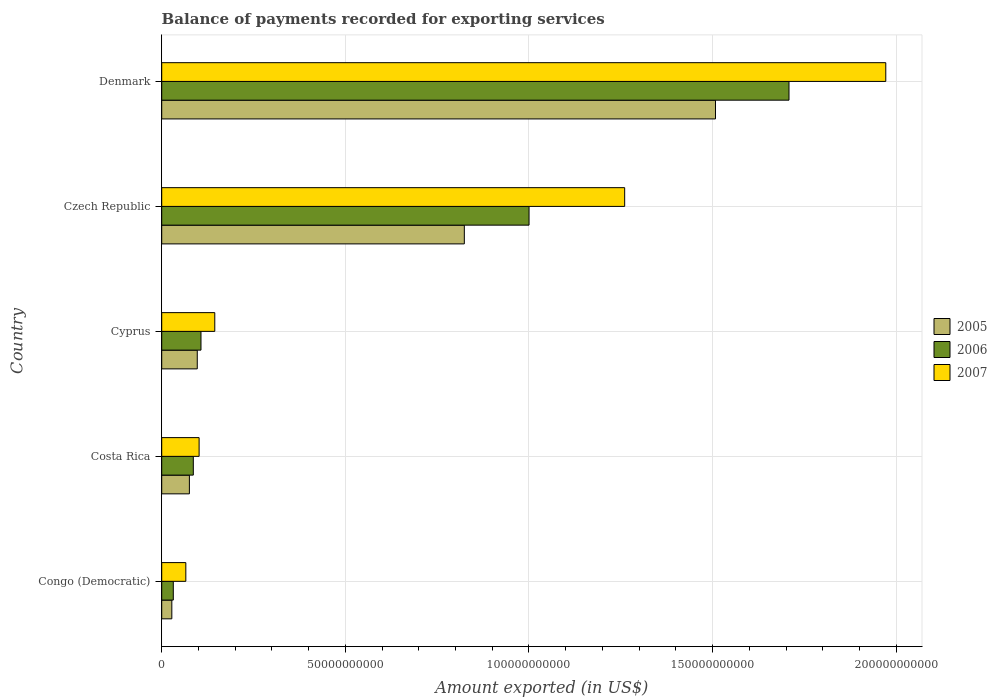How many groups of bars are there?
Provide a succinct answer. 5. Are the number of bars per tick equal to the number of legend labels?
Keep it short and to the point. Yes. What is the label of the 1st group of bars from the top?
Give a very brief answer. Denmark. In how many cases, is the number of bars for a given country not equal to the number of legend labels?
Give a very brief answer. 0. What is the amount exported in 2006 in Cyprus?
Keep it short and to the point. 1.07e+1. Across all countries, what is the maximum amount exported in 2005?
Ensure brevity in your answer.  1.51e+11. Across all countries, what is the minimum amount exported in 2006?
Your answer should be compact. 3.16e+09. In which country was the amount exported in 2007 maximum?
Your answer should be compact. Denmark. In which country was the amount exported in 2007 minimum?
Offer a very short reply. Congo (Democratic). What is the total amount exported in 2005 in the graph?
Give a very brief answer. 2.53e+11. What is the difference between the amount exported in 2005 in Congo (Democratic) and that in Denmark?
Ensure brevity in your answer.  -1.48e+11. What is the difference between the amount exported in 2007 in Cyprus and the amount exported in 2005 in Congo (Democratic)?
Provide a short and direct response. 1.17e+1. What is the average amount exported in 2005 per country?
Provide a succinct answer. 5.06e+1. What is the difference between the amount exported in 2005 and amount exported in 2007 in Czech Republic?
Your answer should be very brief. -4.37e+1. In how many countries, is the amount exported in 2007 greater than 140000000000 US$?
Your answer should be very brief. 1. What is the ratio of the amount exported in 2007 in Cyprus to that in Czech Republic?
Ensure brevity in your answer.  0.11. Is the amount exported in 2005 in Congo (Democratic) less than that in Cyprus?
Provide a succinct answer. Yes. What is the difference between the highest and the second highest amount exported in 2006?
Ensure brevity in your answer.  7.08e+1. What is the difference between the highest and the lowest amount exported in 2006?
Offer a very short reply. 1.68e+11. Is the sum of the amount exported in 2005 in Costa Rica and Denmark greater than the maximum amount exported in 2007 across all countries?
Provide a short and direct response. No. What does the 2nd bar from the top in Cyprus represents?
Provide a short and direct response. 2006. Is it the case that in every country, the sum of the amount exported in 2005 and amount exported in 2006 is greater than the amount exported in 2007?
Provide a succinct answer. No. How many bars are there?
Provide a short and direct response. 15. How many countries are there in the graph?
Your answer should be very brief. 5. What is the difference between two consecutive major ticks on the X-axis?
Provide a short and direct response. 5.00e+1. Are the values on the major ticks of X-axis written in scientific E-notation?
Make the answer very short. No. What is the title of the graph?
Your answer should be very brief. Balance of payments recorded for exporting services. Does "1995" appear as one of the legend labels in the graph?
Your answer should be very brief. No. What is the label or title of the X-axis?
Your answer should be compact. Amount exported (in US$). What is the Amount exported (in US$) of 2005 in Congo (Democratic)?
Make the answer very short. 2.76e+09. What is the Amount exported (in US$) of 2006 in Congo (Democratic)?
Keep it short and to the point. 3.16e+09. What is the Amount exported (in US$) in 2007 in Congo (Democratic)?
Give a very brief answer. 6.57e+09. What is the Amount exported (in US$) of 2005 in Costa Rica?
Ensure brevity in your answer.  7.54e+09. What is the Amount exported (in US$) in 2006 in Costa Rica?
Your response must be concise. 8.60e+09. What is the Amount exported (in US$) in 2007 in Costa Rica?
Your response must be concise. 1.02e+1. What is the Amount exported (in US$) in 2005 in Cyprus?
Your answer should be very brief. 9.68e+09. What is the Amount exported (in US$) of 2006 in Cyprus?
Give a very brief answer. 1.07e+1. What is the Amount exported (in US$) of 2007 in Cyprus?
Provide a succinct answer. 1.44e+1. What is the Amount exported (in US$) of 2005 in Czech Republic?
Make the answer very short. 8.24e+1. What is the Amount exported (in US$) in 2006 in Czech Republic?
Keep it short and to the point. 1.00e+11. What is the Amount exported (in US$) in 2007 in Czech Republic?
Keep it short and to the point. 1.26e+11. What is the Amount exported (in US$) in 2005 in Denmark?
Provide a short and direct response. 1.51e+11. What is the Amount exported (in US$) in 2006 in Denmark?
Offer a very short reply. 1.71e+11. What is the Amount exported (in US$) of 2007 in Denmark?
Your answer should be compact. 1.97e+11. Across all countries, what is the maximum Amount exported (in US$) in 2005?
Ensure brevity in your answer.  1.51e+11. Across all countries, what is the maximum Amount exported (in US$) of 2006?
Keep it short and to the point. 1.71e+11. Across all countries, what is the maximum Amount exported (in US$) in 2007?
Provide a succinct answer. 1.97e+11. Across all countries, what is the minimum Amount exported (in US$) of 2005?
Your answer should be compact. 2.76e+09. Across all countries, what is the minimum Amount exported (in US$) in 2006?
Make the answer very short. 3.16e+09. Across all countries, what is the minimum Amount exported (in US$) of 2007?
Make the answer very short. 6.57e+09. What is the total Amount exported (in US$) of 2005 in the graph?
Ensure brevity in your answer.  2.53e+11. What is the total Amount exported (in US$) of 2006 in the graph?
Keep it short and to the point. 2.93e+11. What is the total Amount exported (in US$) in 2007 in the graph?
Keep it short and to the point. 3.54e+11. What is the difference between the Amount exported (in US$) in 2005 in Congo (Democratic) and that in Costa Rica?
Make the answer very short. -4.78e+09. What is the difference between the Amount exported (in US$) of 2006 in Congo (Democratic) and that in Costa Rica?
Your answer should be very brief. -5.45e+09. What is the difference between the Amount exported (in US$) in 2007 in Congo (Democratic) and that in Costa Rica?
Offer a very short reply. -3.62e+09. What is the difference between the Amount exported (in US$) of 2005 in Congo (Democratic) and that in Cyprus?
Your response must be concise. -6.93e+09. What is the difference between the Amount exported (in US$) of 2006 in Congo (Democratic) and that in Cyprus?
Your answer should be compact. -7.54e+09. What is the difference between the Amount exported (in US$) in 2007 in Congo (Democratic) and that in Cyprus?
Keep it short and to the point. -7.88e+09. What is the difference between the Amount exported (in US$) in 2005 in Congo (Democratic) and that in Czech Republic?
Your answer should be compact. -7.96e+1. What is the difference between the Amount exported (in US$) in 2006 in Congo (Democratic) and that in Czech Republic?
Make the answer very short. -9.69e+1. What is the difference between the Amount exported (in US$) of 2007 in Congo (Democratic) and that in Czech Republic?
Your answer should be compact. -1.19e+11. What is the difference between the Amount exported (in US$) in 2005 in Congo (Democratic) and that in Denmark?
Your answer should be very brief. -1.48e+11. What is the difference between the Amount exported (in US$) in 2006 in Congo (Democratic) and that in Denmark?
Provide a succinct answer. -1.68e+11. What is the difference between the Amount exported (in US$) of 2007 in Congo (Democratic) and that in Denmark?
Make the answer very short. -1.91e+11. What is the difference between the Amount exported (in US$) in 2005 in Costa Rica and that in Cyprus?
Give a very brief answer. -2.15e+09. What is the difference between the Amount exported (in US$) in 2006 in Costa Rica and that in Cyprus?
Your response must be concise. -2.09e+09. What is the difference between the Amount exported (in US$) of 2007 in Costa Rica and that in Cyprus?
Provide a succinct answer. -4.27e+09. What is the difference between the Amount exported (in US$) in 2005 in Costa Rica and that in Czech Republic?
Give a very brief answer. -7.49e+1. What is the difference between the Amount exported (in US$) in 2006 in Costa Rica and that in Czech Republic?
Your answer should be compact. -9.14e+1. What is the difference between the Amount exported (in US$) in 2007 in Costa Rica and that in Czech Republic?
Offer a terse response. -1.16e+11. What is the difference between the Amount exported (in US$) in 2005 in Costa Rica and that in Denmark?
Offer a very short reply. -1.43e+11. What is the difference between the Amount exported (in US$) of 2006 in Costa Rica and that in Denmark?
Provide a short and direct response. -1.62e+11. What is the difference between the Amount exported (in US$) in 2007 in Costa Rica and that in Denmark?
Offer a very short reply. -1.87e+11. What is the difference between the Amount exported (in US$) in 2005 in Cyprus and that in Czech Republic?
Your answer should be compact. -7.27e+1. What is the difference between the Amount exported (in US$) in 2006 in Cyprus and that in Czech Republic?
Your response must be concise. -8.93e+1. What is the difference between the Amount exported (in US$) of 2007 in Cyprus and that in Czech Republic?
Ensure brevity in your answer.  -1.12e+11. What is the difference between the Amount exported (in US$) of 2005 in Cyprus and that in Denmark?
Provide a short and direct response. -1.41e+11. What is the difference between the Amount exported (in US$) of 2006 in Cyprus and that in Denmark?
Give a very brief answer. -1.60e+11. What is the difference between the Amount exported (in US$) of 2007 in Cyprus and that in Denmark?
Provide a short and direct response. -1.83e+11. What is the difference between the Amount exported (in US$) of 2005 in Czech Republic and that in Denmark?
Your response must be concise. -6.84e+1. What is the difference between the Amount exported (in US$) in 2006 in Czech Republic and that in Denmark?
Provide a short and direct response. -7.08e+1. What is the difference between the Amount exported (in US$) of 2007 in Czech Republic and that in Denmark?
Give a very brief answer. -7.11e+1. What is the difference between the Amount exported (in US$) in 2005 in Congo (Democratic) and the Amount exported (in US$) in 2006 in Costa Rica?
Give a very brief answer. -5.85e+09. What is the difference between the Amount exported (in US$) in 2005 in Congo (Democratic) and the Amount exported (in US$) in 2007 in Costa Rica?
Ensure brevity in your answer.  -7.43e+09. What is the difference between the Amount exported (in US$) of 2006 in Congo (Democratic) and the Amount exported (in US$) of 2007 in Costa Rica?
Give a very brief answer. -7.03e+09. What is the difference between the Amount exported (in US$) of 2005 in Congo (Democratic) and the Amount exported (in US$) of 2006 in Cyprus?
Your response must be concise. -7.94e+09. What is the difference between the Amount exported (in US$) in 2005 in Congo (Democratic) and the Amount exported (in US$) in 2007 in Cyprus?
Give a very brief answer. -1.17e+1. What is the difference between the Amount exported (in US$) in 2006 in Congo (Democratic) and the Amount exported (in US$) in 2007 in Cyprus?
Keep it short and to the point. -1.13e+1. What is the difference between the Amount exported (in US$) in 2005 in Congo (Democratic) and the Amount exported (in US$) in 2006 in Czech Republic?
Your answer should be very brief. -9.73e+1. What is the difference between the Amount exported (in US$) in 2005 in Congo (Democratic) and the Amount exported (in US$) in 2007 in Czech Republic?
Make the answer very short. -1.23e+11. What is the difference between the Amount exported (in US$) in 2006 in Congo (Democratic) and the Amount exported (in US$) in 2007 in Czech Republic?
Give a very brief answer. -1.23e+11. What is the difference between the Amount exported (in US$) of 2005 in Congo (Democratic) and the Amount exported (in US$) of 2006 in Denmark?
Ensure brevity in your answer.  -1.68e+11. What is the difference between the Amount exported (in US$) of 2005 in Congo (Democratic) and the Amount exported (in US$) of 2007 in Denmark?
Make the answer very short. -1.94e+11. What is the difference between the Amount exported (in US$) in 2006 in Congo (Democratic) and the Amount exported (in US$) in 2007 in Denmark?
Keep it short and to the point. -1.94e+11. What is the difference between the Amount exported (in US$) of 2005 in Costa Rica and the Amount exported (in US$) of 2006 in Cyprus?
Offer a very short reply. -3.16e+09. What is the difference between the Amount exported (in US$) of 2005 in Costa Rica and the Amount exported (in US$) of 2007 in Cyprus?
Keep it short and to the point. -6.91e+09. What is the difference between the Amount exported (in US$) of 2006 in Costa Rica and the Amount exported (in US$) of 2007 in Cyprus?
Provide a succinct answer. -5.84e+09. What is the difference between the Amount exported (in US$) in 2005 in Costa Rica and the Amount exported (in US$) in 2006 in Czech Republic?
Ensure brevity in your answer.  -9.25e+1. What is the difference between the Amount exported (in US$) in 2005 in Costa Rica and the Amount exported (in US$) in 2007 in Czech Republic?
Offer a very short reply. -1.19e+11. What is the difference between the Amount exported (in US$) in 2006 in Costa Rica and the Amount exported (in US$) in 2007 in Czech Republic?
Provide a short and direct response. -1.17e+11. What is the difference between the Amount exported (in US$) in 2005 in Costa Rica and the Amount exported (in US$) in 2006 in Denmark?
Your response must be concise. -1.63e+11. What is the difference between the Amount exported (in US$) of 2005 in Costa Rica and the Amount exported (in US$) of 2007 in Denmark?
Provide a succinct answer. -1.90e+11. What is the difference between the Amount exported (in US$) of 2006 in Costa Rica and the Amount exported (in US$) of 2007 in Denmark?
Your answer should be compact. -1.89e+11. What is the difference between the Amount exported (in US$) in 2005 in Cyprus and the Amount exported (in US$) in 2006 in Czech Republic?
Make the answer very short. -9.03e+1. What is the difference between the Amount exported (in US$) of 2005 in Cyprus and the Amount exported (in US$) of 2007 in Czech Republic?
Your answer should be very brief. -1.16e+11. What is the difference between the Amount exported (in US$) in 2006 in Cyprus and the Amount exported (in US$) in 2007 in Czech Republic?
Give a very brief answer. -1.15e+11. What is the difference between the Amount exported (in US$) in 2005 in Cyprus and the Amount exported (in US$) in 2006 in Denmark?
Your response must be concise. -1.61e+11. What is the difference between the Amount exported (in US$) of 2005 in Cyprus and the Amount exported (in US$) of 2007 in Denmark?
Offer a terse response. -1.87e+11. What is the difference between the Amount exported (in US$) of 2006 in Cyprus and the Amount exported (in US$) of 2007 in Denmark?
Provide a succinct answer. -1.86e+11. What is the difference between the Amount exported (in US$) in 2005 in Czech Republic and the Amount exported (in US$) in 2006 in Denmark?
Offer a terse response. -8.84e+1. What is the difference between the Amount exported (in US$) in 2005 in Czech Republic and the Amount exported (in US$) in 2007 in Denmark?
Keep it short and to the point. -1.15e+11. What is the difference between the Amount exported (in US$) of 2006 in Czech Republic and the Amount exported (in US$) of 2007 in Denmark?
Ensure brevity in your answer.  -9.71e+1. What is the average Amount exported (in US$) of 2005 per country?
Make the answer very short. 5.06e+1. What is the average Amount exported (in US$) in 2006 per country?
Give a very brief answer. 5.87e+1. What is the average Amount exported (in US$) in 2007 per country?
Keep it short and to the point. 7.09e+1. What is the difference between the Amount exported (in US$) in 2005 and Amount exported (in US$) in 2006 in Congo (Democratic)?
Make the answer very short. -4.00e+08. What is the difference between the Amount exported (in US$) in 2005 and Amount exported (in US$) in 2007 in Congo (Democratic)?
Offer a terse response. -3.81e+09. What is the difference between the Amount exported (in US$) of 2006 and Amount exported (in US$) of 2007 in Congo (Democratic)?
Offer a terse response. -3.41e+09. What is the difference between the Amount exported (in US$) in 2005 and Amount exported (in US$) in 2006 in Costa Rica?
Your answer should be very brief. -1.07e+09. What is the difference between the Amount exported (in US$) of 2005 and Amount exported (in US$) of 2007 in Costa Rica?
Provide a succinct answer. -2.65e+09. What is the difference between the Amount exported (in US$) in 2006 and Amount exported (in US$) in 2007 in Costa Rica?
Provide a succinct answer. -1.58e+09. What is the difference between the Amount exported (in US$) in 2005 and Amount exported (in US$) in 2006 in Cyprus?
Give a very brief answer. -1.01e+09. What is the difference between the Amount exported (in US$) of 2005 and Amount exported (in US$) of 2007 in Cyprus?
Ensure brevity in your answer.  -4.77e+09. What is the difference between the Amount exported (in US$) in 2006 and Amount exported (in US$) in 2007 in Cyprus?
Keep it short and to the point. -3.76e+09. What is the difference between the Amount exported (in US$) in 2005 and Amount exported (in US$) in 2006 in Czech Republic?
Provide a short and direct response. -1.76e+1. What is the difference between the Amount exported (in US$) in 2005 and Amount exported (in US$) in 2007 in Czech Republic?
Give a very brief answer. -4.37e+1. What is the difference between the Amount exported (in US$) in 2006 and Amount exported (in US$) in 2007 in Czech Republic?
Provide a short and direct response. -2.60e+1. What is the difference between the Amount exported (in US$) of 2005 and Amount exported (in US$) of 2006 in Denmark?
Ensure brevity in your answer.  -2.00e+1. What is the difference between the Amount exported (in US$) in 2005 and Amount exported (in US$) in 2007 in Denmark?
Offer a terse response. -4.64e+1. What is the difference between the Amount exported (in US$) of 2006 and Amount exported (in US$) of 2007 in Denmark?
Provide a succinct answer. -2.64e+1. What is the ratio of the Amount exported (in US$) of 2005 in Congo (Democratic) to that in Costa Rica?
Keep it short and to the point. 0.37. What is the ratio of the Amount exported (in US$) in 2006 in Congo (Democratic) to that in Costa Rica?
Keep it short and to the point. 0.37. What is the ratio of the Amount exported (in US$) of 2007 in Congo (Democratic) to that in Costa Rica?
Offer a very short reply. 0.64. What is the ratio of the Amount exported (in US$) in 2005 in Congo (Democratic) to that in Cyprus?
Give a very brief answer. 0.28. What is the ratio of the Amount exported (in US$) in 2006 in Congo (Democratic) to that in Cyprus?
Keep it short and to the point. 0.3. What is the ratio of the Amount exported (in US$) in 2007 in Congo (Democratic) to that in Cyprus?
Offer a terse response. 0.45. What is the ratio of the Amount exported (in US$) in 2005 in Congo (Democratic) to that in Czech Republic?
Provide a succinct answer. 0.03. What is the ratio of the Amount exported (in US$) of 2006 in Congo (Democratic) to that in Czech Republic?
Your answer should be compact. 0.03. What is the ratio of the Amount exported (in US$) of 2007 in Congo (Democratic) to that in Czech Republic?
Provide a succinct answer. 0.05. What is the ratio of the Amount exported (in US$) of 2005 in Congo (Democratic) to that in Denmark?
Give a very brief answer. 0.02. What is the ratio of the Amount exported (in US$) of 2006 in Congo (Democratic) to that in Denmark?
Provide a short and direct response. 0.02. What is the ratio of the Amount exported (in US$) in 2007 in Congo (Democratic) to that in Denmark?
Offer a terse response. 0.03. What is the ratio of the Amount exported (in US$) of 2005 in Costa Rica to that in Cyprus?
Make the answer very short. 0.78. What is the ratio of the Amount exported (in US$) of 2006 in Costa Rica to that in Cyprus?
Give a very brief answer. 0.8. What is the ratio of the Amount exported (in US$) in 2007 in Costa Rica to that in Cyprus?
Offer a terse response. 0.7. What is the ratio of the Amount exported (in US$) in 2005 in Costa Rica to that in Czech Republic?
Make the answer very short. 0.09. What is the ratio of the Amount exported (in US$) of 2006 in Costa Rica to that in Czech Republic?
Give a very brief answer. 0.09. What is the ratio of the Amount exported (in US$) of 2007 in Costa Rica to that in Czech Republic?
Offer a terse response. 0.08. What is the ratio of the Amount exported (in US$) in 2006 in Costa Rica to that in Denmark?
Keep it short and to the point. 0.05. What is the ratio of the Amount exported (in US$) of 2007 in Costa Rica to that in Denmark?
Provide a short and direct response. 0.05. What is the ratio of the Amount exported (in US$) of 2005 in Cyprus to that in Czech Republic?
Your answer should be very brief. 0.12. What is the ratio of the Amount exported (in US$) in 2006 in Cyprus to that in Czech Republic?
Your response must be concise. 0.11. What is the ratio of the Amount exported (in US$) in 2007 in Cyprus to that in Czech Republic?
Your answer should be compact. 0.11. What is the ratio of the Amount exported (in US$) in 2005 in Cyprus to that in Denmark?
Keep it short and to the point. 0.06. What is the ratio of the Amount exported (in US$) in 2006 in Cyprus to that in Denmark?
Keep it short and to the point. 0.06. What is the ratio of the Amount exported (in US$) of 2007 in Cyprus to that in Denmark?
Make the answer very short. 0.07. What is the ratio of the Amount exported (in US$) of 2005 in Czech Republic to that in Denmark?
Keep it short and to the point. 0.55. What is the ratio of the Amount exported (in US$) of 2006 in Czech Republic to that in Denmark?
Your answer should be compact. 0.59. What is the ratio of the Amount exported (in US$) of 2007 in Czech Republic to that in Denmark?
Keep it short and to the point. 0.64. What is the difference between the highest and the second highest Amount exported (in US$) in 2005?
Your answer should be very brief. 6.84e+1. What is the difference between the highest and the second highest Amount exported (in US$) in 2006?
Your answer should be very brief. 7.08e+1. What is the difference between the highest and the second highest Amount exported (in US$) in 2007?
Offer a very short reply. 7.11e+1. What is the difference between the highest and the lowest Amount exported (in US$) of 2005?
Your response must be concise. 1.48e+11. What is the difference between the highest and the lowest Amount exported (in US$) in 2006?
Keep it short and to the point. 1.68e+11. What is the difference between the highest and the lowest Amount exported (in US$) in 2007?
Provide a succinct answer. 1.91e+11. 